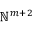Convert formula to latex. <formula><loc_0><loc_0><loc_500><loc_500>\mathbb { N } ^ { m + 2 }</formula> 